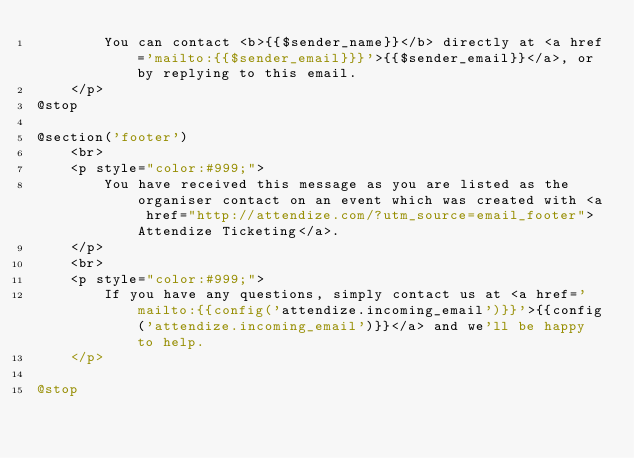<code> <loc_0><loc_0><loc_500><loc_500><_PHP_>        You can contact <b>{{$sender_name}}</b> directly at <a href='mailto:{{$sender_email}}}'>{{$sender_email}}</a>, or by replying to this email.
    </p>
@stop

@section('footer')
    <br>
    <p style="color:#999;">
        You have received this message as you are listed as the organiser contact on an event which was created with <a href="http://attendize.com/?utm_source=email_footer">Attendize Ticketing</a>.
    </p>
    <br>
    <p style="color:#999;">
        If you have any questions, simply contact us at <a href='mailto:{{config('attendize.incoming_email')}}'>{{config('attendize.incoming_email')}}</a> and we'll be happy to help.
    </p>

@stop
</code> 